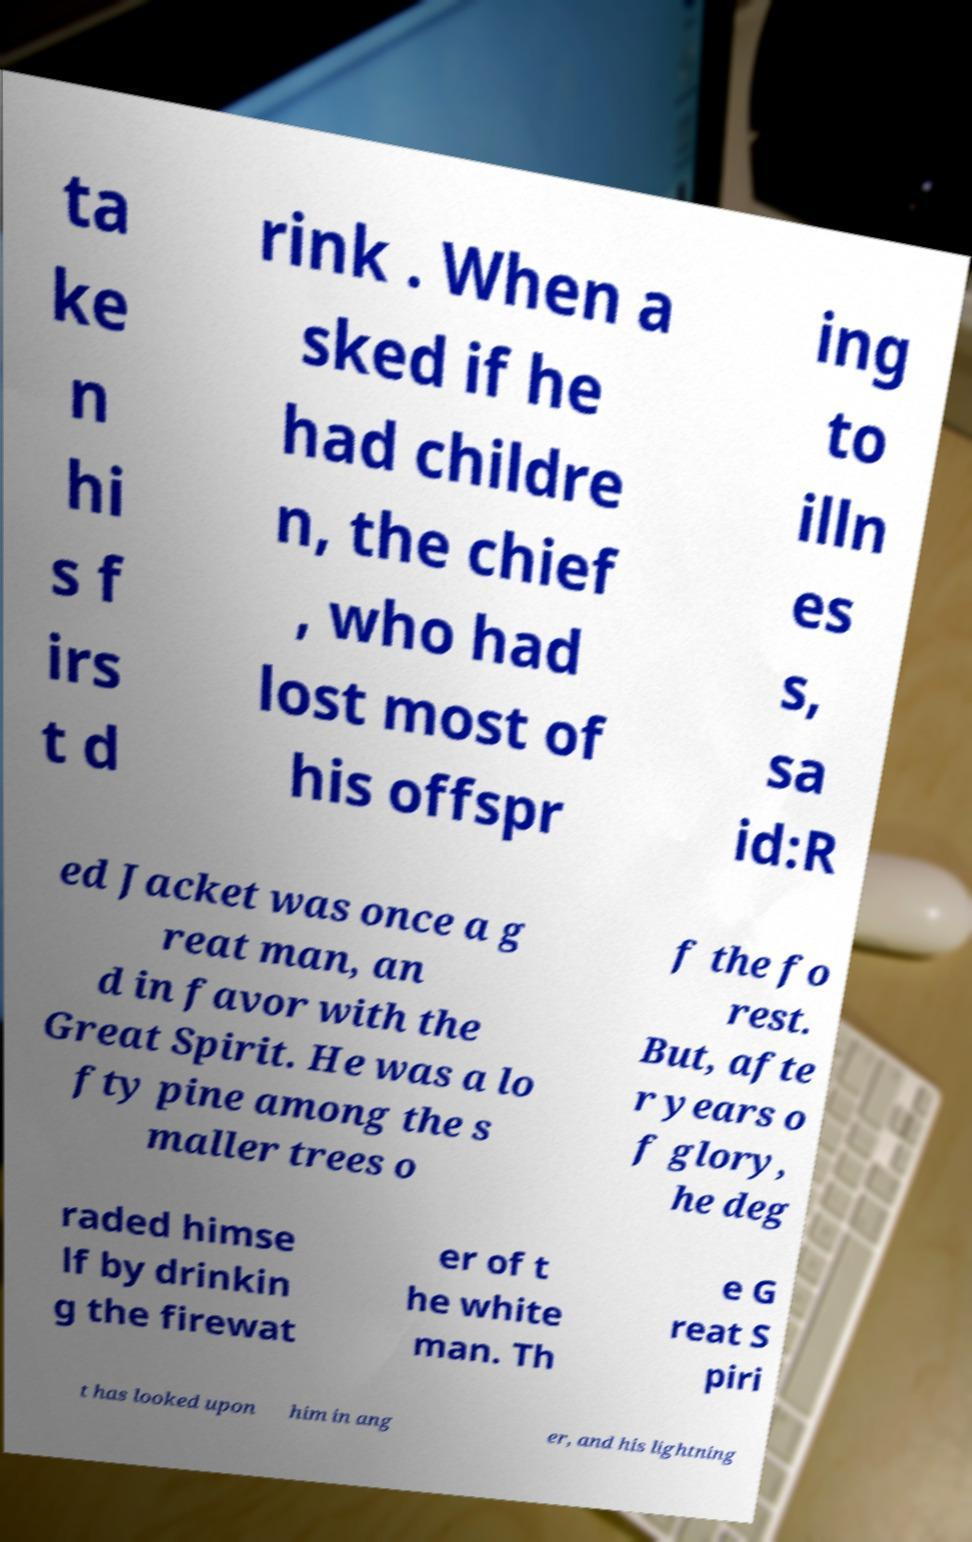Could you extract and type out the text from this image? ta ke n hi s f irs t d rink . When a sked if he had childre n, the chief , who had lost most of his offspr ing to illn es s, sa id:R ed Jacket was once a g reat man, an d in favor with the Great Spirit. He was a lo fty pine among the s maller trees o f the fo rest. But, afte r years o f glory, he deg raded himse lf by drinkin g the firewat er of t he white man. Th e G reat S piri t has looked upon him in ang er, and his lightning 